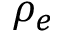Convert formula to latex. <formula><loc_0><loc_0><loc_500><loc_500>\rho _ { e }</formula> 